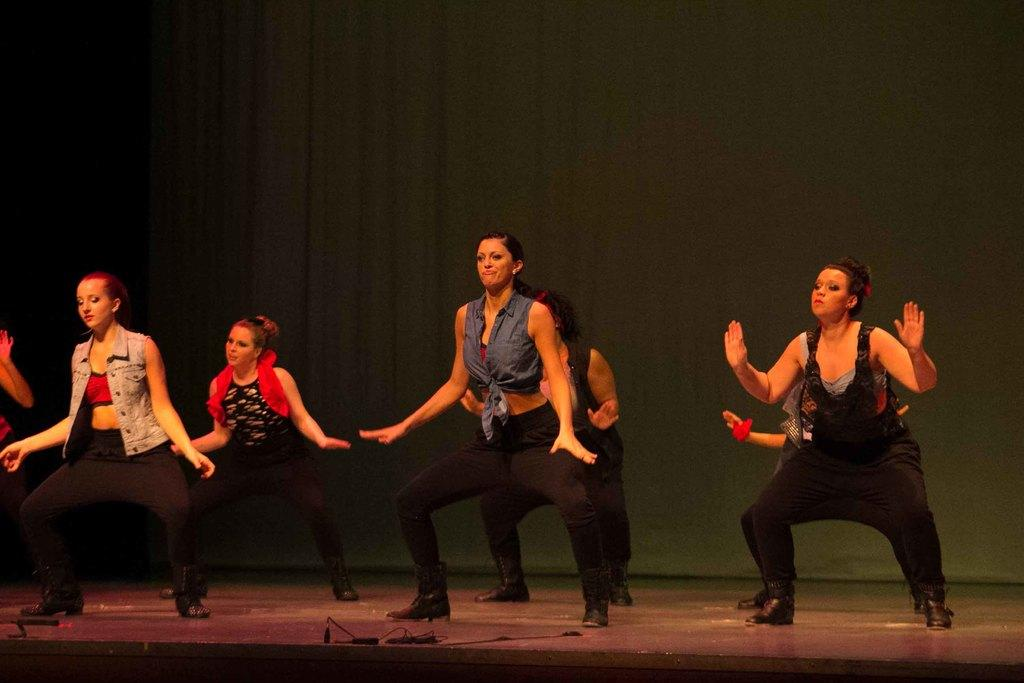What is happening in the image? There are women in the image, and they are dancing. Where are the women performing their dance? The women are on a stage. What type of scarf is being used by the women to generate power in the image? There is no scarf present in the image, nor is there any indication of power generation. 